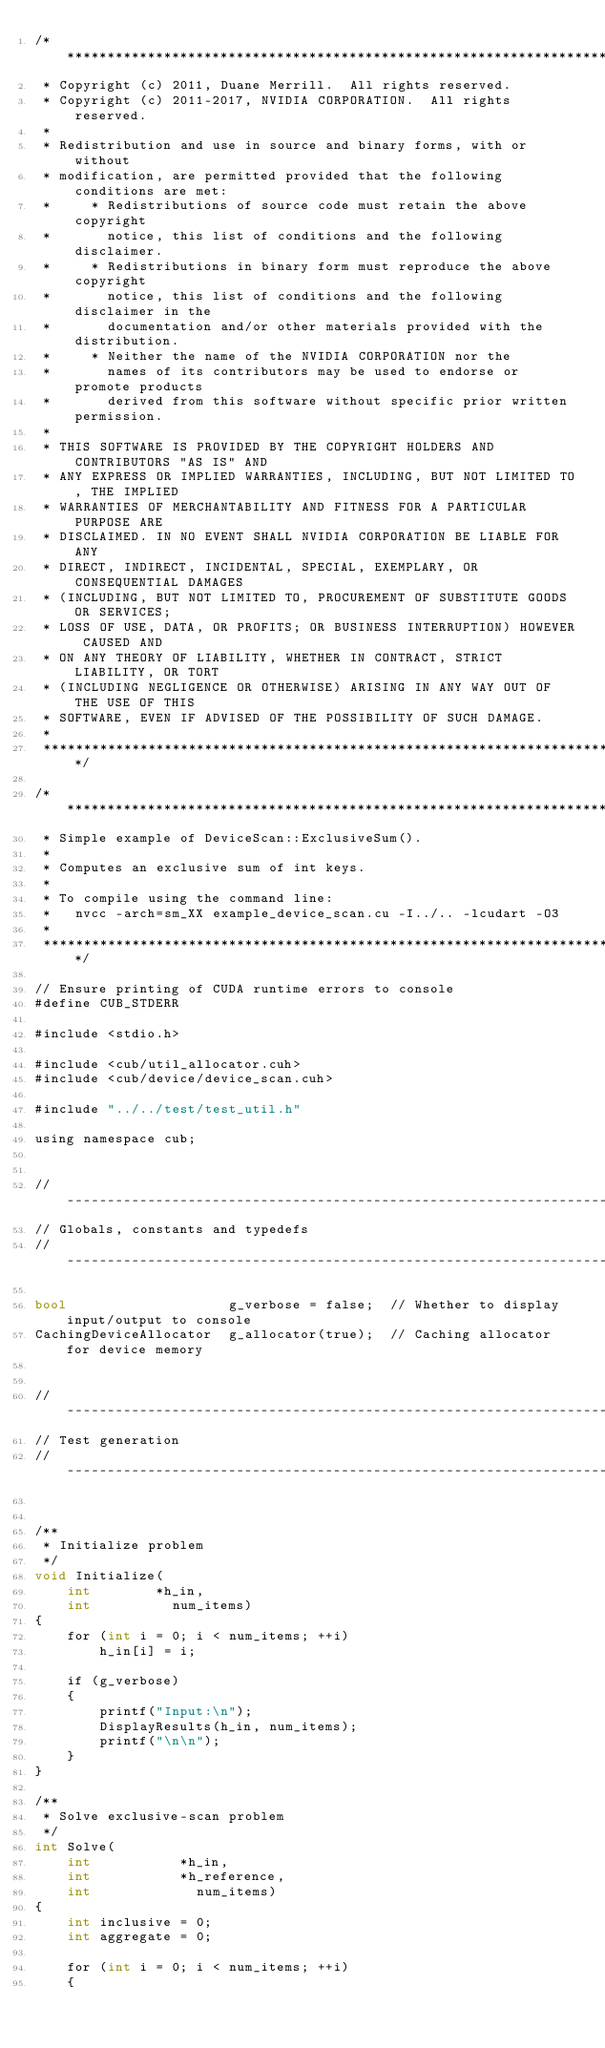<code> <loc_0><loc_0><loc_500><loc_500><_Cuda_>/******************************************************************************
 * Copyright (c) 2011, Duane Merrill.  All rights reserved.
 * Copyright (c) 2011-2017, NVIDIA CORPORATION.  All rights reserved.
 *
 * Redistribution and use in source and binary forms, with or without
 * modification, are permitted provided that the following conditions are met:
 *     * Redistributions of source code must retain the above copyright
 *       notice, this list of conditions and the following disclaimer.
 *     * Redistributions in binary form must reproduce the above copyright
 *       notice, this list of conditions and the following disclaimer in the
 *       documentation and/or other materials provided with the distribution.
 *     * Neither the name of the NVIDIA CORPORATION nor the
 *       names of its contributors may be used to endorse or promote products
 *       derived from this software without specific prior written permission.
 *
 * THIS SOFTWARE IS PROVIDED BY THE COPYRIGHT HOLDERS AND CONTRIBUTORS "AS IS" AND
 * ANY EXPRESS OR IMPLIED WARRANTIES, INCLUDING, BUT NOT LIMITED TO, THE IMPLIED
 * WARRANTIES OF MERCHANTABILITY AND FITNESS FOR A PARTICULAR PURPOSE ARE
 * DISCLAIMED. IN NO EVENT SHALL NVIDIA CORPORATION BE LIABLE FOR ANY
 * DIRECT, INDIRECT, INCIDENTAL, SPECIAL, EXEMPLARY, OR CONSEQUENTIAL DAMAGES
 * (INCLUDING, BUT NOT LIMITED TO, PROCUREMENT OF SUBSTITUTE GOODS OR SERVICES;
 * LOSS OF USE, DATA, OR PROFITS; OR BUSINESS INTERRUPTION) HOWEVER CAUSED AND
 * ON ANY THEORY OF LIABILITY, WHETHER IN CONTRACT, STRICT LIABILITY, OR TORT
 * (INCLUDING NEGLIGENCE OR OTHERWISE) ARISING IN ANY WAY OUT OF THE USE OF THIS
 * SOFTWARE, EVEN IF ADVISED OF THE POSSIBILITY OF SUCH DAMAGE.
 *
 ******************************************************************************/

/******************************************************************************
 * Simple example of DeviceScan::ExclusiveSum().
 *
 * Computes an exclusive sum of int keys.
 *
 * To compile using the command line:
 *   nvcc -arch=sm_XX example_device_scan.cu -I../.. -lcudart -O3
 *
 ******************************************************************************/

// Ensure printing of CUDA runtime errors to console
#define CUB_STDERR

#include <stdio.h>

#include <cub/util_allocator.cuh>
#include <cub/device/device_scan.cuh>

#include "../../test/test_util.h"

using namespace cub;


//---------------------------------------------------------------------
// Globals, constants and typedefs
//---------------------------------------------------------------------

bool                    g_verbose = false;  // Whether to display input/output to console
CachingDeviceAllocator  g_allocator(true);  // Caching allocator for device memory


//---------------------------------------------------------------------
// Test generation
//---------------------------------------------------------------------


/**
 * Initialize problem
 */
void Initialize(
    int        *h_in,
    int          num_items)
{
    for (int i = 0; i < num_items; ++i)
        h_in[i] = i;

    if (g_verbose)
    {
        printf("Input:\n");
        DisplayResults(h_in, num_items);
        printf("\n\n");
    }
}

/**
 * Solve exclusive-scan problem
 */
int Solve(
    int           *h_in,
    int           *h_reference,
    int             num_items)
{
    int inclusive = 0;
    int aggregate = 0;

    for (int i = 0; i < num_items; ++i)
    {</code> 